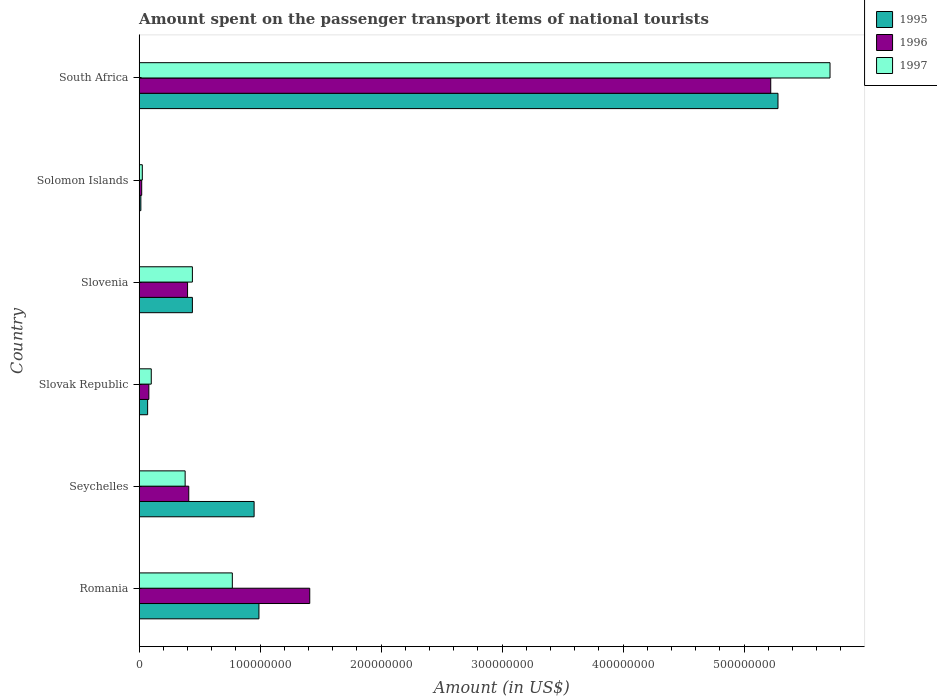How many groups of bars are there?
Your response must be concise. 6. Are the number of bars per tick equal to the number of legend labels?
Offer a very short reply. Yes. Are the number of bars on each tick of the Y-axis equal?
Your response must be concise. Yes. How many bars are there on the 5th tick from the top?
Your answer should be very brief. 3. What is the label of the 4th group of bars from the top?
Make the answer very short. Slovak Republic. In how many cases, is the number of bars for a given country not equal to the number of legend labels?
Offer a very short reply. 0. What is the amount spent on the passenger transport items of national tourists in 1995 in Seychelles?
Provide a short and direct response. 9.50e+07. Across all countries, what is the maximum amount spent on the passenger transport items of national tourists in 1996?
Offer a terse response. 5.22e+08. Across all countries, what is the minimum amount spent on the passenger transport items of national tourists in 1995?
Provide a succinct answer. 1.40e+06. In which country was the amount spent on the passenger transport items of national tourists in 1997 maximum?
Give a very brief answer. South Africa. In which country was the amount spent on the passenger transport items of national tourists in 1997 minimum?
Offer a very short reply. Solomon Islands. What is the total amount spent on the passenger transport items of national tourists in 1995 in the graph?
Give a very brief answer. 7.74e+08. What is the difference between the amount spent on the passenger transport items of national tourists in 1996 in Romania and that in Slovak Republic?
Provide a short and direct response. 1.33e+08. What is the difference between the amount spent on the passenger transport items of national tourists in 1997 in Solomon Islands and the amount spent on the passenger transport items of national tourists in 1996 in South Africa?
Offer a terse response. -5.19e+08. What is the average amount spent on the passenger transport items of national tourists in 1995 per country?
Your answer should be compact. 1.29e+08. What is the difference between the amount spent on the passenger transport items of national tourists in 1996 and amount spent on the passenger transport items of national tourists in 1995 in South Africa?
Keep it short and to the point. -6.00e+06. What is the ratio of the amount spent on the passenger transport items of national tourists in 1997 in Solomon Islands to that in South Africa?
Your answer should be compact. 0. What is the difference between the highest and the second highest amount spent on the passenger transport items of national tourists in 1995?
Offer a terse response. 4.29e+08. What is the difference between the highest and the lowest amount spent on the passenger transport items of national tourists in 1995?
Give a very brief answer. 5.27e+08. Is the sum of the amount spent on the passenger transport items of national tourists in 1995 in Romania and Slovenia greater than the maximum amount spent on the passenger transport items of national tourists in 1996 across all countries?
Keep it short and to the point. No. What does the 3rd bar from the top in South Africa represents?
Your answer should be compact. 1995. Are the values on the major ticks of X-axis written in scientific E-notation?
Your answer should be very brief. No. Does the graph contain any zero values?
Your answer should be compact. No. Does the graph contain grids?
Provide a short and direct response. No. What is the title of the graph?
Offer a terse response. Amount spent on the passenger transport items of national tourists. What is the Amount (in US$) of 1995 in Romania?
Your response must be concise. 9.90e+07. What is the Amount (in US$) in 1996 in Romania?
Offer a very short reply. 1.41e+08. What is the Amount (in US$) in 1997 in Romania?
Offer a very short reply. 7.70e+07. What is the Amount (in US$) in 1995 in Seychelles?
Your answer should be compact. 9.50e+07. What is the Amount (in US$) of 1996 in Seychelles?
Your answer should be compact. 4.10e+07. What is the Amount (in US$) in 1997 in Seychelles?
Your response must be concise. 3.80e+07. What is the Amount (in US$) of 1995 in Slovenia?
Your response must be concise. 4.40e+07. What is the Amount (in US$) of 1996 in Slovenia?
Your answer should be compact. 4.00e+07. What is the Amount (in US$) of 1997 in Slovenia?
Your response must be concise. 4.40e+07. What is the Amount (in US$) of 1995 in Solomon Islands?
Ensure brevity in your answer.  1.40e+06. What is the Amount (in US$) of 1996 in Solomon Islands?
Make the answer very short. 2.10e+06. What is the Amount (in US$) in 1997 in Solomon Islands?
Make the answer very short. 2.60e+06. What is the Amount (in US$) of 1995 in South Africa?
Provide a succinct answer. 5.28e+08. What is the Amount (in US$) of 1996 in South Africa?
Ensure brevity in your answer.  5.22e+08. What is the Amount (in US$) of 1997 in South Africa?
Offer a very short reply. 5.71e+08. Across all countries, what is the maximum Amount (in US$) of 1995?
Give a very brief answer. 5.28e+08. Across all countries, what is the maximum Amount (in US$) in 1996?
Keep it short and to the point. 5.22e+08. Across all countries, what is the maximum Amount (in US$) of 1997?
Your answer should be compact. 5.71e+08. Across all countries, what is the minimum Amount (in US$) of 1995?
Your answer should be very brief. 1.40e+06. Across all countries, what is the minimum Amount (in US$) of 1996?
Your answer should be very brief. 2.10e+06. Across all countries, what is the minimum Amount (in US$) in 1997?
Offer a very short reply. 2.60e+06. What is the total Amount (in US$) in 1995 in the graph?
Provide a succinct answer. 7.74e+08. What is the total Amount (in US$) of 1996 in the graph?
Offer a terse response. 7.54e+08. What is the total Amount (in US$) in 1997 in the graph?
Provide a succinct answer. 7.43e+08. What is the difference between the Amount (in US$) in 1995 in Romania and that in Seychelles?
Offer a very short reply. 4.00e+06. What is the difference between the Amount (in US$) of 1997 in Romania and that in Seychelles?
Your answer should be compact. 3.90e+07. What is the difference between the Amount (in US$) of 1995 in Romania and that in Slovak Republic?
Your answer should be compact. 9.20e+07. What is the difference between the Amount (in US$) in 1996 in Romania and that in Slovak Republic?
Your answer should be very brief. 1.33e+08. What is the difference between the Amount (in US$) of 1997 in Romania and that in Slovak Republic?
Your answer should be compact. 6.70e+07. What is the difference between the Amount (in US$) in 1995 in Romania and that in Slovenia?
Ensure brevity in your answer.  5.50e+07. What is the difference between the Amount (in US$) in 1996 in Romania and that in Slovenia?
Your answer should be very brief. 1.01e+08. What is the difference between the Amount (in US$) in 1997 in Romania and that in Slovenia?
Make the answer very short. 3.30e+07. What is the difference between the Amount (in US$) of 1995 in Romania and that in Solomon Islands?
Your response must be concise. 9.76e+07. What is the difference between the Amount (in US$) in 1996 in Romania and that in Solomon Islands?
Keep it short and to the point. 1.39e+08. What is the difference between the Amount (in US$) in 1997 in Romania and that in Solomon Islands?
Ensure brevity in your answer.  7.44e+07. What is the difference between the Amount (in US$) of 1995 in Romania and that in South Africa?
Ensure brevity in your answer.  -4.29e+08. What is the difference between the Amount (in US$) of 1996 in Romania and that in South Africa?
Provide a short and direct response. -3.81e+08. What is the difference between the Amount (in US$) in 1997 in Romania and that in South Africa?
Make the answer very short. -4.94e+08. What is the difference between the Amount (in US$) of 1995 in Seychelles and that in Slovak Republic?
Your response must be concise. 8.80e+07. What is the difference between the Amount (in US$) of 1996 in Seychelles and that in Slovak Republic?
Offer a terse response. 3.30e+07. What is the difference between the Amount (in US$) of 1997 in Seychelles and that in Slovak Republic?
Your answer should be very brief. 2.80e+07. What is the difference between the Amount (in US$) of 1995 in Seychelles and that in Slovenia?
Keep it short and to the point. 5.10e+07. What is the difference between the Amount (in US$) of 1997 in Seychelles and that in Slovenia?
Ensure brevity in your answer.  -6.00e+06. What is the difference between the Amount (in US$) in 1995 in Seychelles and that in Solomon Islands?
Your answer should be very brief. 9.36e+07. What is the difference between the Amount (in US$) in 1996 in Seychelles and that in Solomon Islands?
Provide a short and direct response. 3.89e+07. What is the difference between the Amount (in US$) in 1997 in Seychelles and that in Solomon Islands?
Ensure brevity in your answer.  3.54e+07. What is the difference between the Amount (in US$) in 1995 in Seychelles and that in South Africa?
Provide a short and direct response. -4.33e+08. What is the difference between the Amount (in US$) of 1996 in Seychelles and that in South Africa?
Your answer should be very brief. -4.81e+08. What is the difference between the Amount (in US$) in 1997 in Seychelles and that in South Africa?
Your answer should be compact. -5.33e+08. What is the difference between the Amount (in US$) in 1995 in Slovak Republic and that in Slovenia?
Provide a succinct answer. -3.70e+07. What is the difference between the Amount (in US$) of 1996 in Slovak Republic and that in Slovenia?
Provide a short and direct response. -3.20e+07. What is the difference between the Amount (in US$) of 1997 in Slovak Republic and that in Slovenia?
Offer a terse response. -3.40e+07. What is the difference between the Amount (in US$) in 1995 in Slovak Republic and that in Solomon Islands?
Your answer should be compact. 5.60e+06. What is the difference between the Amount (in US$) of 1996 in Slovak Republic and that in Solomon Islands?
Your answer should be very brief. 5.90e+06. What is the difference between the Amount (in US$) in 1997 in Slovak Republic and that in Solomon Islands?
Make the answer very short. 7.40e+06. What is the difference between the Amount (in US$) of 1995 in Slovak Republic and that in South Africa?
Your answer should be compact. -5.21e+08. What is the difference between the Amount (in US$) in 1996 in Slovak Republic and that in South Africa?
Make the answer very short. -5.14e+08. What is the difference between the Amount (in US$) in 1997 in Slovak Republic and that in South Africa?
Your answer should be very brief. -5.61e+08. What is the difference between the Amount (in US$) of 1995 in Slovenia and that in Solomon Islands?
Your response must be concise. 4.26e+07. What is the difference between the Amount (in US$) in 1996 in Slovenia and that in Solomon Islands?
Ensure brevity in your answer.  3.79e+07. What is the difference between the Amount (in US$) in 1997 in Slovenia and that in Solomon Islands?
Offer a terse response. 4.14e+07. What is the difference between the Amount (in US$) in 1995 in Slovenia and that in South Africa?
Provide a succinct answer. -4.84e+08. What is the difference between the Amount (in US$) in 1996 in Slovenia and that in South Africa?
Your response must be concise. -4.82e+08. What is the difference between the Amount (in US$) of 1997 in Slovenia and that in South Africa?
Keep it short and to the point. -5.27e+08. What is the difference between the Amount (in US$) in 1995 in Solomon Islands and that in South Africa?
Provide a succinct answer. -5.27e+08. What is the difference between the Amount (in US$) of 1996 in Solomon Islands and that in South Africa?
Make the answer very short. -5.20e+08. What is the difference between the Amount (in US$) of 1997 in Solomon Islands and that in South Africa?
Provide a short and direct response. -5.68e+08. What is the difference between the Amount (in US$) of 1995 in Romania and the Amount (in US$) of 1996 in Seychelles?
Your answer should be very brief. 5.80e+07. What is the difference between the Amount (in US$) in 1995 in Romania and the Amount (in US$) in 1997 in Seychelles?
Give a very brief answer. 6.10e+07. What is the difference between the Amount (in US$) of 1996 in Romania and the Amount (in US$) of 1997 in Seychelles?
Ensure brevity in your answer.  1.03e+08. What is the difference between the Amount (in US$) in 1995 in Romania and the Amount (in US$) in 1996 in Slovak Republic?
Keep it short and to the point. 9.10e+07. What is the difference between the Amount (in US$) of 1995 in Romania and the Amount (in US$) of 1997 in Slovak Republic?
Make the answer very short. 8.90e+07. What is the difference between the Amount (in US$) of 1996 in Romania and the Amount (in US$) of 1997 in Slovak Republic?
Your response must be concise. 1.31e+08. What is the difference between the Amount (in US$) of 1995 in Romania and the Amount (in US$) of 1996 in Slovenia?
Keep it short and to the point. 5.90e+07. What is the difference between the Amount (in US$) of 1995 in Romania and the Amount (in US$) of 1997 in Slovenia?
Ensure brevity in your answer.  5.50e+07. What is the difference between the Amount (in US$) in 1996 in Romania and the Amount (in US$) in 1997 in Slovenia?
Ensure brevity in your answer.  9.70e+07. What is the difference between the Amount (in US$) of 1995 in Romania and the Amount (in US$) of 1996 in Solomon Islands?
Your response must be concise. 9.69e+07. What is the difference between the Amount (in US$) in 1995 in Romania and the Amount (in US$) in 1997 in Solomon Islands?
Your response must be concise. 9.64e+07. What is the difference between the Amount (in US$) of 1996 in Romania and the Amount (in US$) of 1997 in Solomon Islands?
Provide a succinct answer. 1.38e+08. What is the difference between the Amount (in US$) in 1995 in Romania and the Amount (in US$) in 1996 in South Africa?
Your answer should be very brief. -4.23e+08. What is the difference between the Amount (in US$) of 1995 in Romania and the Amount (in US$) of 1997 in South Africa?
Give a very brief answer. -4.72e+08. What is the difference between the Amount (in US$) in 1996 in Romania and the Amount (in US$) in 1997 in South Africa?
Make the answer very short. -4.30e+08. What is the difference between the Amount (in US$) in 1995 in Seychelles and the Amount (in US$) in 1996 in Slovak Republic?
Provide a short and direct response. 8.70e+07. What is the difference between the Amount (in US$) in 1995 in Seychelles and the Amount (in US$) in 1997 in Slovak Republic?
Make the answer very short. 8.50e+07. What is the difference between the Amount (in US$) of 1996 in Seychelles and the Amount (in US$) of 1997 in Slovak Republic?
Your response must be concise. 3.10e+07. What is the difference between the Amount (in US$) of 1995 in Seychelles and the Amount (in US$) of 1996 in Slovenia?
Your answer should be very brief. 5.50e+07. What is the difference between the Amount (in US$) of 1995 in Seychelles and the Amount (in US$) of 1997 in Slovenia?
Your response must be concise. 5.10e+07. What is the difference between the Amount (in US$) in 1995 in Seychelles and the Amount (in US$) in 1996 in Solomon Islands?
Make the answer very short. 9.29e+07. What is the difference between the Amount (in US$) in 1995 in Seychelles and the Amount (in US$) in 1997 in Solomon Islands?
Your answer should be compact. 9.24e+07. What is the difference between the Amount (in US$) of 1996 in Seychelles and the Amount (in US$) of 1997 in Solomon Islands?
Provide a succinct answer. 3.84e+07. What is the difference between the Amount (in US$) in 1995 in Seychelles and the Amount (in US$) in 1996 in South Africa?
Ensure brevity in your answer.  -4.27e+08. What is the difference between the Amount (in US$) in 1995 in Seychelles and the Amount (in US$) in 1997 in South Africa?
Make the answer very short. -4.76e+08. What is the difference between the Amount (in US$) in 1996 in Seychelles and the Amount (in US$) in 1997 in South Africa?
Give a very brief answer. -5.30e+08. What is the difference between the Amount (in US$) in 1995 in Slovak Republic and the Amount (in US$) in 1996 in Slovenia?
Your response must be concise. -3.30e+07. What is the difference between the Amount (in US$) in 1995 in Slovak Republic and the Amount (in US$) in 1997 in Slovenia?
Offer a terse response. -3.70e+07. What is the difference between the Amount (in US$) in 1996 in Slovak Republic and the Amount (in US$) in 1997 in Slovenia?
Provide a succinct answer. -3.60e+07. What is the difference between the Amount (in US$) of 1995 in Slovak Republic and the Amount (in US$) of 1996 in Solomon Islands?
Make the answer very short. 4.90e+06. What is the difference between the Amount (in US$) in 1995 in Slovak Republic and the Amount (in US$) in 1997 in Solomon Islands?
Give a very brief answer. 4.40e+06. What is the difference between the Amount (in US$) of 1996 in Slovak Republic and the Amount (in US$) of 1997 in Solomon Islands?
Make the answer very short. 5.40e+06. What is the difference between the Amount (in US$) of 1995 in Slovak Republic and the Amount (in US$) of 1996 in South Africa?
Give a very brief answer. -5.15e+08. What is the difference between the Amount (in US$) of 1995 in Slovak Republic and the Amount (in US$) of 1997 in South Africa?
Keep it short and to the point. -5.64e+08. What is the difference between the Amount (in US$) in 1996 in Slovak Republic and the Amount (in US$) in 1997 in South Africa?
Keep it short and to the point. -5.63e+08. What is the difference between the Amount (in US$) in 1995 in Slovenia and the Amount (in US$) in 1996 in Solomon Islands?
Ensure brevity in your answer.  4.19e+07. What is the difference between the Amount (in US$) in 1995 in Slovenia and the Amount (in US$) in 1997 in Solomon Islands?
Keep it short and to the point. 4.14e+07. What is the difference between the Amount (in US$) in 1996 in Slovenia and the Amount (in US$) in 1997 in Solomon Islands?
Provide a succinct answer. 3.74e+07. What is the difference between the Amount (in US$) of 1995 in Slovenia and the Amount (in US$) of 1996 in South Africa?
Provide a succinct answer. -4.78e+08. What is the difference between the Amount (in US$) of 1995 in Slovenia and the Amount (in US$) of 1997 in South Africa?
Your answer should be very brief. -5.27e+08. What is the difference between the Amount (in US$) of 1996 in Slovenia and the Amount (in US$) of 1997 in South Africa?
Your response must be concise. -5.31e+08. What is the difference between the Amount (in US$) of 1995 in Solomon Islands and the Amount (in US$) of 1996 in South Africa?
Provide a short and direct response. -5.21e+08. What is the difference between the Amount (in US$) in 1995 in Solomon Islands and the Amount (in US$) in 1997 in South Africa?
Ensure brevity in your answer.  -5.70e+08. What is the difference between the Amount (in US$) of 1996 in Solomon Islands and the Amount (in US$) of 1997 in South Africa?
Your answer should be compact. -5.69e+08. What is the average Amount (in US$) in 1995 per country?
Ensure brevity in your answer.  1.29e+08. What is the average Amount (in US$) in 1996 per country?
Your answer should be very brief. 1.26e+08. What is the average Amount (in US$) in 1997 per country?
Make the answer very short. 1.24e+08. What is the difference between the Amount (in US$) in 1995 and Amount (in US$) in 1996 in Romania?
Provide a succinct answer. -4.20e+07. What is the difference between the Amount (in US$) of 1995 and Amount (in US$) of 1997 in Romania?
Provide a succinct answer. 2.20e+07. What is the difference between the Amount (in US$) of 1996 and Amount (in US$) of 1997 in Romania?
Offer a very short reply. 6.40e+07. What is the difference between the Amount (in US$) in 1995 and Amount (in US$) in 1996 in Seychelles?
Give a very brief answer. 5.40e+07. What is the difference between the Amount (in US$) of 1995 and Amount (in US$) of 1997 in Seychelles?
Give a very brief answer. 5.70e+07. What is the difference between the Amount (in US$) in 1995 and Amount (in US$) in 1997 in Slovenia?
Your answer should be compact. 0. What is the difference between the Amount (in US$) in 1995 and Amount (in US$) in 1996 in Solomon Islands?
Provide a short and direct response. -7.00e+05. What is the difference between the Amount (in US$) of 1995 and Amount (in US$) of 1997 in Solomon Islands?
Your answer should be compact. -1.20e+06. What is the difference between the Amount (in US$) of 1996 and Amount (in US$) of 1997 in Solomon Islands?
Offer a terse response. -5.00e+05. What is the difference between the Amount (in US$) of 1995 and Amount (in US$) of 1996 in South Africa?
Your response must be concise. 6.00e+06. What is the difference between the Amount (in US$) of 1995 and Amount (in US$) of 1997 in South Africa?
Make the answer very short. -4.30e+07. What is the difference between the Amount (in US$) of 1996 and Amount (in US$) of 1997 in South Africa?
Keep it short and to the point. -4.90e+07. What is the ratio of the Amount (in US$) of 1995 in Romania to that in Seychelles?
Give a very brief answer. 1.04. What is the ratio of the Amount (in US$) of 1996 in Romania to that in Seychelles?
Provide a short and direct response. 3.44. What is the ratio of the Amount (in US$) of 1997 in Romania to that in Seychelles?
Offer a very short reply. 2.03. What is the ratio of the Amount (in US$) of 1995 in Romania to that in Slovak Republic?
Provide a succinct answer. 14.14. What is the ratio of the Amount (in US$) of 1996 in Romania to that in Slovak Republic?
Ensure brevity in your answer.  17.62. What is the ratio of the Amount (in US$) of 1997 in Romania to that in Slovak Republic?
Provide a succinct answer. 7.7. What is the ratio of the Amount (in US$) in 1995 in Romania to that in Slovenia?
Keep it short and to the point. 2.25. What is the ratio of the Amount (in US$) of 1996 in Romania to that in Slovenia?
Give a very brief answer. 3.52. What is the ratio of the Amount (in US$) in 1995 in Romania to that in Solomon Islands?
Keep it short and to the point. 70.71. What is the ratio of the Amount (in US$) in 1996 in Romania to that in Solomon Islands?
Ensure brevity in your answer.  67.14. What is the ratio of the Amount (in US$) in 1997 in Romania to that in Solomon Islands?
Give a very brief answer. 29.62. What is the ratio of the Amount (in US$) in 1995 in Romania to that in South Africa?
Keep it short and to the point. 0.19. What is the ratio of the Amount (in US$) in 1996 in Romania to that in South Africa?
Provide a short and direct response. 0.27. What is the ratio of the Amount (in US$) in 1997 in Romania to that in South Africa?
Give a very brief answer. 0.13. What is the ratio of the Amount (in US$) of 1995 in Seychelles to that in Slovak Republic?
Offer a terse response. 13.57. What is the ratio of the Amount (in US$) in 1996 in Seychelles to that in Slovak Republic?
Keep it short and to the point. 5.12. What is the ratio of the Amount (in US$) in 1995 in Seychelles to that in Slovenia?
Provide a succinct answer. 2.16. What is the ratio of the Amount (in US$) in 1996 in Seychelles to that in Slovenia?
Offer a very short reply. 1.02. What is the ratio of the Amount (in US$) of 1997 in Seychelles to that in Slovenia?
Keep it short and to the point. 0.86. What is the ratio of the Amount (in US$) in 1995 in Seychelles to that in Solomon Islands?
Your answer should be very brief. 67.86. What is the ratio of the Amount (in US$) in 1996 in Seychelles to that in Solomon Islands?
Your answer should be compact. 19.52. What is the ratio of the Amount (in US$) in 1997 in Seychelles to that in Solomon Islands?
Provide a succinct answer. 14.62. What is the ratio of the Amount (in US$) in 1995 in Seychelles to that in South Africa?
Your answer should be compact. 0.18. What is the ratio of the Amount (in US$) of 1996 in Seychelles to that in South Africa?
Make the answer very short. 0.08. What is the ratio of the Amount (in US$) of 1997 in Seychelles to that in South Africa?
Keep it short and to the point. 0.07. What is the ratio of the Amount (in US$) of 1995 in Slovak Republic to that in Slovenia?
Ensure brevity in your answer.  0.16. What is the ratio of the Amount (in US$) of 1996 in Slovak Republic to that in Slovenia?
Offer a terse response. 0.2. What is the ratio of the Amount (in US$) of 1997 in Slovak Republic to that in Slovenia?
Offer a very short reply. 0.23. What is the ratio of the Amount (in US$) of 1996 in Slovak Republic to that in Solomon Islands?
Your answer should be compact. 3.81. What is the ratio of the Amount (in US$) in 1997 in Slovak Republic to that in Solomon Islands?
Keep it short and to the point. 3.85. What is the ratio of the Amount (in US$) in 1995 in Slovak Republic to that in South Africa?
Keep it short and to the point. 0.01. What is the ratio of the Amount (in US$) of 1996 in Slovak Republic to that in South Africa?
Your answer should be very brief. 0.02. What is the ratio of the Amount (in US$) of 1997 in Slovak Republic to that in South Africa?
Ensure brevity in your answer.  0.02. What is the ratio of the Amount (in US$) in 1995 in Slovenia to that in Solomon Islands?
Provide a succinct answer. 31.43. What is the ratio of the Amount (in US$) in 1996 in Slovenia to that in Solomon Islands?
Offer a very short reply. 19.05. What is the ratio of the Amount (in US$) in 1997 in Slovenia to that in Solomon Islands?
Give a very brief answer. 16.92. What is the ratio of the Amount (in US$) of 1995 in Slovenia to that in South Africa?
Make the answer very short. 0.08. What is the ratio of the Amount (in US$) of 1996 in Slovenia to that in South Africa?
Offer a very short reply. 0.08. What is the ratio of the Amount (in US$) of 1997 in Slovenia to that in South Africa?
Your answer should be very brief. 0.08. What is the ratio of the Amount (in US$) in 1995 in Solomon Islands to that in South Africa?
Give a very brief answer. 0. What is the ratio of the Amount (in US$) in 1996 in Solomon Islands to that in South Africa?
Provide a succinct answer. 0. What is the ratio of the Amount (in US$) in 1997 in Solomon Islands to that in South Africa?
Give a very brief answer. 0. What is the difference between the highest and the second highest Amount (in US$) of 1995?
Ensure brevity in your answer.  4.29e+08. What is the difference between the highest and the second highest Amount (in US$) of 1996?
Offer a very short reply. 3.81e+08. What is the difference between the highest and the second highest Amount (in US$) in 1997?
Give a very brief answer. 4.94e+08. What is the difference between the highest and the lowest Amount (in US$) in 1995?
Your answer should be very brief. 5.27e+08. What is the difference between the highest and the lowest Amount (in US$) of 1996?
Offer a terse response. 5.20e+08. What is the difference between the highest and the lowest Amount (in US$) in 1997?
Provide a succinct answer. 5.68e+08. 